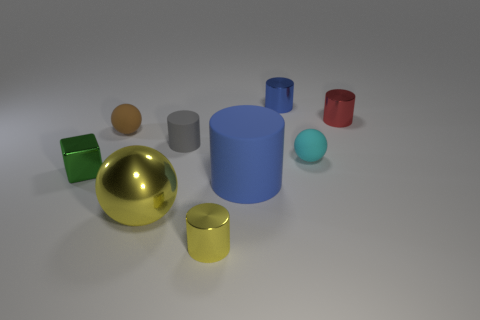Is there any other thing that has the same shape as the small green object?
Offer a very short reply. No. The blue rubber thing that is the same shape as the tiny red metal thing is what size?
Provide a short and direct response. Large. How many other things are made of the same material as the big yellow thing?
Give a very brief answer. 4. What is the block made of?
Make the answer very short. Metal. There is a sphere on the right side of the small blue metal thing; is it the same color as the tiny cylinder in front of the cyan ball?
Offer a very short reply. No. Is the number of tiny rubber things to the right of the green metallic block greater than the number of spheres?
Give a very brief answer. No. What number of other things are the same color as the big metal thing?
Ensure brevity in your answer.  1. Does the yellow metallic object right of the gray matte cylinder have the same size as the shiny sphere?
Offer a very short reply. No. Is there a brown sphere that has the same size as the blue metal object?
Offer a terse response. Yes. What is the color of the rubber cylinder in front of the tiny block?
Provide a short and direct response. Blue. 